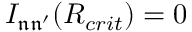Convert formula to latex. <formula><loc_0><loc_0><loc_500><loc_500>I _ { \mathfrak { n } \mathfrak { n ^ { \prime } } } ( R _ { c r i t } ) = 0</formula> 